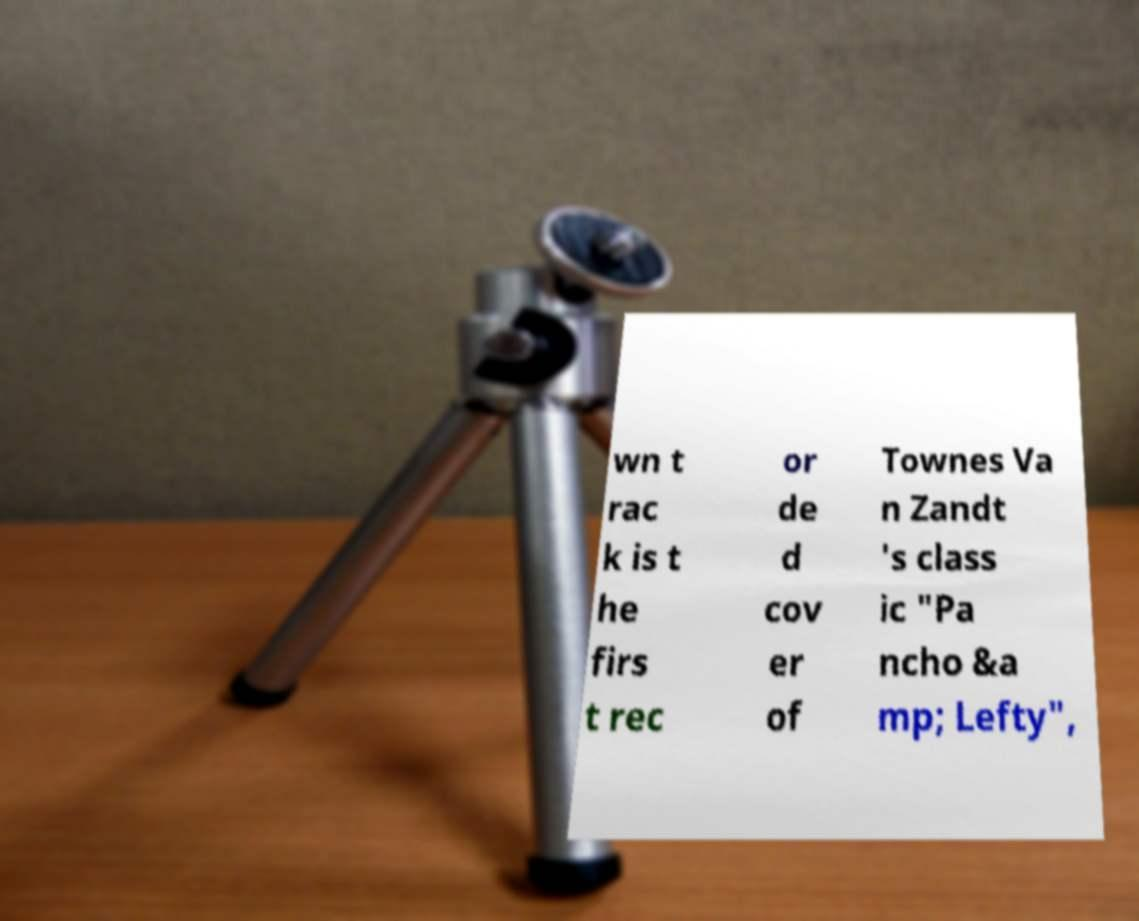What messages or text are displayed in this image? I need them in a readable, typed format. wn t rac k is t he firs t rec or de d cov er of Townes Va n Zandt 's class ic "Pa ncho &a mp; Lefty", 